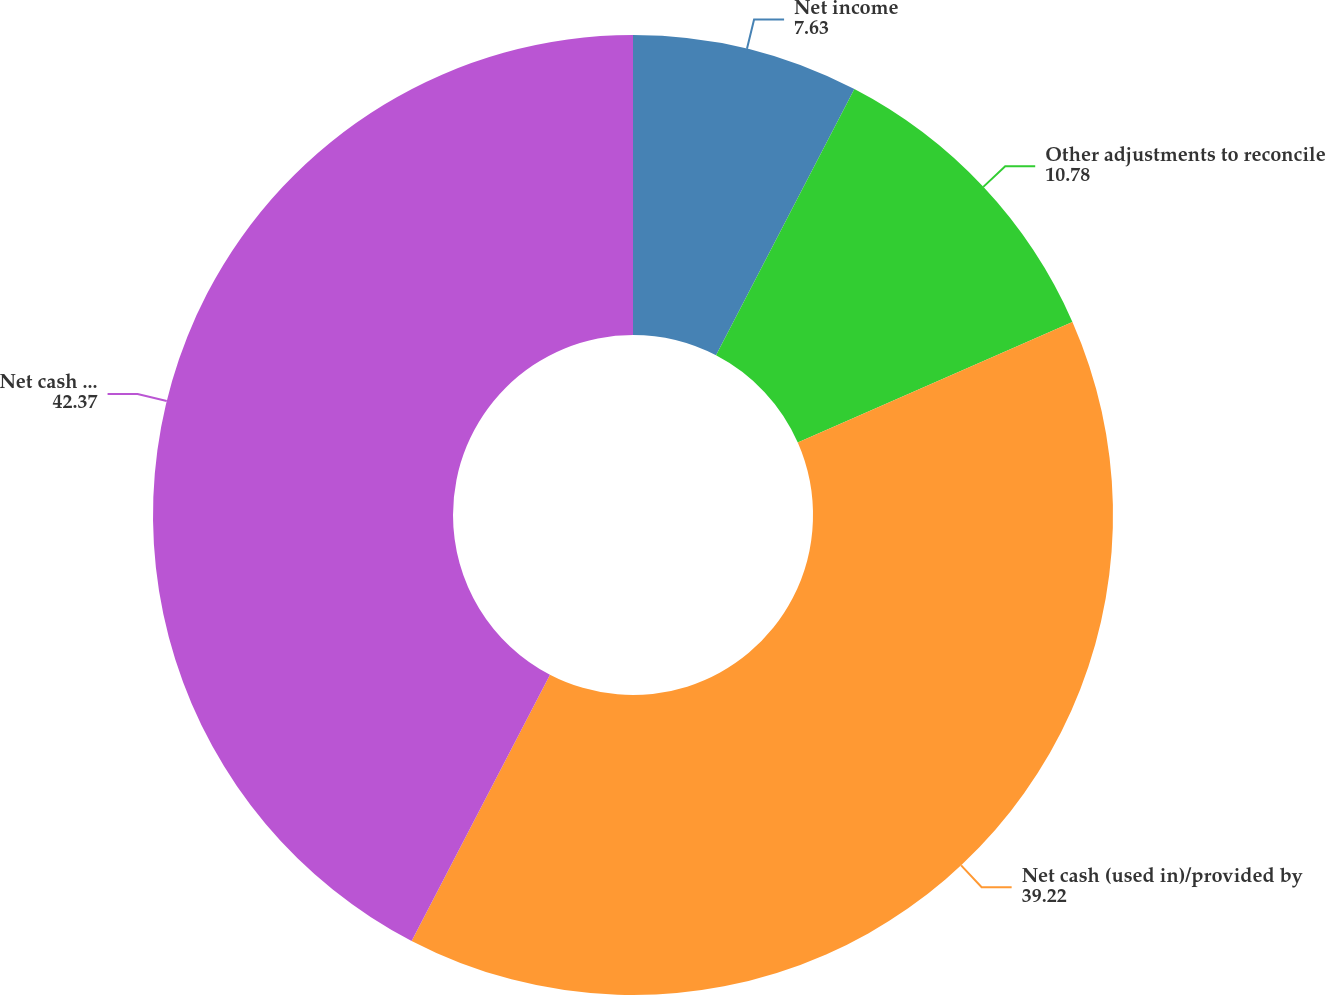Convert chart. <chart><loc_0><loc_0><loc_500><loc_500><pie_chart><fcel>Net income<fcel>Other adjustments to reconcile<fcel>Net cash (used in)/provided by<fcel>Net cash provided by/(used in)<nl><fcel>7.63%<fcel>10.78%<fcel>39.22%<fcel>42.37%<nl></chart> 